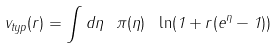<formula> <loc_0><loc_0><loc_500><loc_500>v _ { t y p } ( r ) = \int d \eta \ \pi ( \eta ) \ \ln ( 1 + r ( e ^ { \eta } - 1 ) )</formula> 